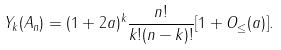<formula> <loc_0><loc_0><loc_500><loc_500>Y _ { k } ( A _ { n } ) = ( 1 + 2 a ) ^ { k } \frac { n ! } { k ! ( n - k ) ! } [ 1 + O _ { \leq } ( a ) ] .</formula> 